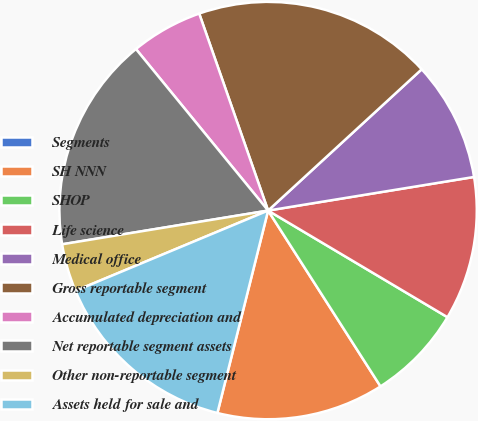<chart> <loc_0><loc_0><loc_500><loc_500><pie_chart><fcel>Segments<fcel>SH NNN<fcel>SHOP<fcel>Life science<fcel>Medical office<fcel>Gross reportable segment<fcel>Accumulated depreciation and<fcel>Net reportable segment assets<fcel>Other non-reportable segment<fcel>Assets held for sale and<nl><fcel>0.0%<fcel>12.96%<fcel>7.41%<fcel>11.11%<fcel>9.26%<fcel>18.52%<fcel>5.56%<fcel>16.67%<fcel>3.7%<fcel>14.81%<nl></chart> 